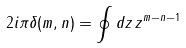Convert formula to latex. <formula><loc_0><loc_0><loc_500><loc_500>2 i \pi \delta ( m , n ) = \oint d z \, z ^ { m - n - 1 }</formula> 